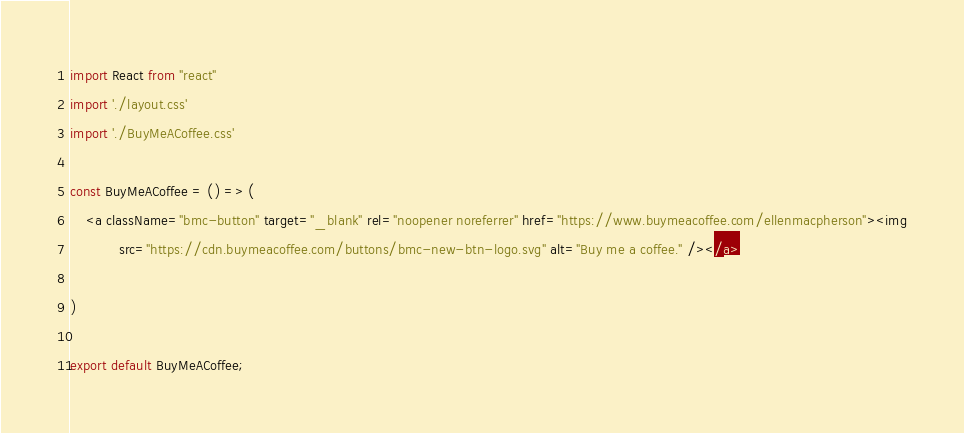Convert code to text. <code><loc_0><loc_0><loc_500><loc_500><_JavaScript_>
import React from "react"
import './layout.css'
import './BuyMeACoffee.css'

const BuyMeACoffee = () => (
    <a className="bmc-button" target="_blank" rel="noopener noreferrer" href="https://www.buymeacoffee.com/ellenmacpherson"><img
            src="https://cdn.buymeacoffee.com/buttons/bmc-new-btn-logo.svg" alt="Buy me a coffee." /></a>

)

export default BuyMeACoffee;




</code> 